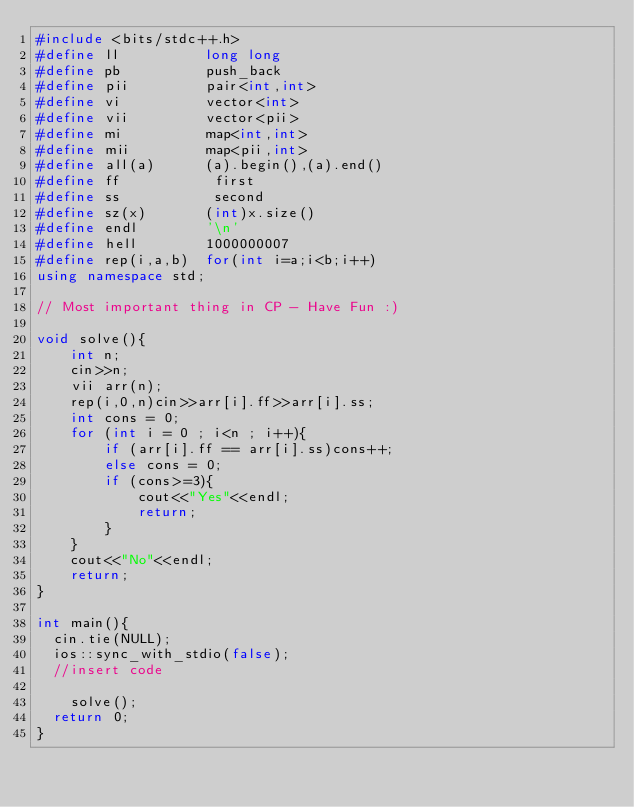<code> <loc_0><loc_0><loc_500><loc_500><_C++_>#include <bits/stdc++.h>
#define ll          long long
#define pb          push_back
#define pii         pair<int,int>
#define vi          vector<int>
#define vii         vector<pii>
#define mi          map<int,int>
#define mii         map<pii,int>
#define all(a)      (a).begin(),(a).end()
#define ff           first
#define ss           second
#define sz(x)       (int)x.size()
#define endl        '\n'
#define hell        1000000007
#define rep(i,a,b)  for(int i=a;i<b;i++)
using namespace std;

// Most important thing in CP - Have Fun :)

void solve(){
    int n;
    cin>>n;
    vii arr(n);
    rep(i,0,n)cin>>arr[i].ff>>arr[i].ss;
    int cons = 0;
    for (int i = 0 ; i<n ; i++){
        if (arr[i].ff == arr[i].ss)cons++;
        else cons = 0;
        if (cons>=3){
            cout<<"Yes"<<endl;
            return;
        }
    }
    cout<<"No"<<endl;
    return;
}

int main(){
	cin.tie(NULL);
	ios::sync_with_stdio(false);
	//insert code
	
		solve();
	return 0;
}</code> 